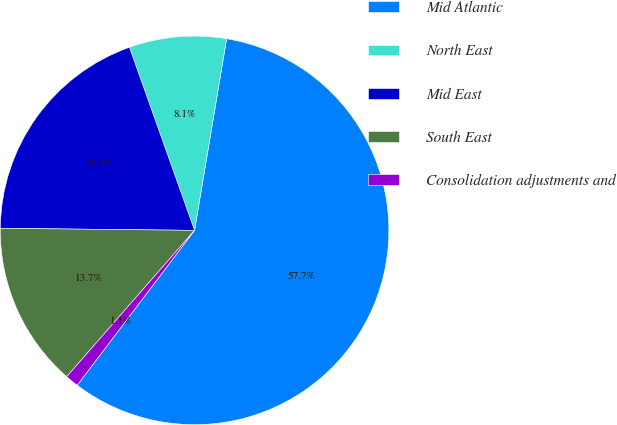Convert chart to OTSL. <chart><loc_0><loc_0><loc_500><loc_500><pie_chart><fcel>Mid Atlantic<fcel>North East<fcel>Mid East<fcel>South East<fcel>Consolidation adjustments and<nl><fcel>57.68%<fcel>8.08%<fcel>19.39%<fcel>13.74%<fcel>1.11%<nl></chart> 